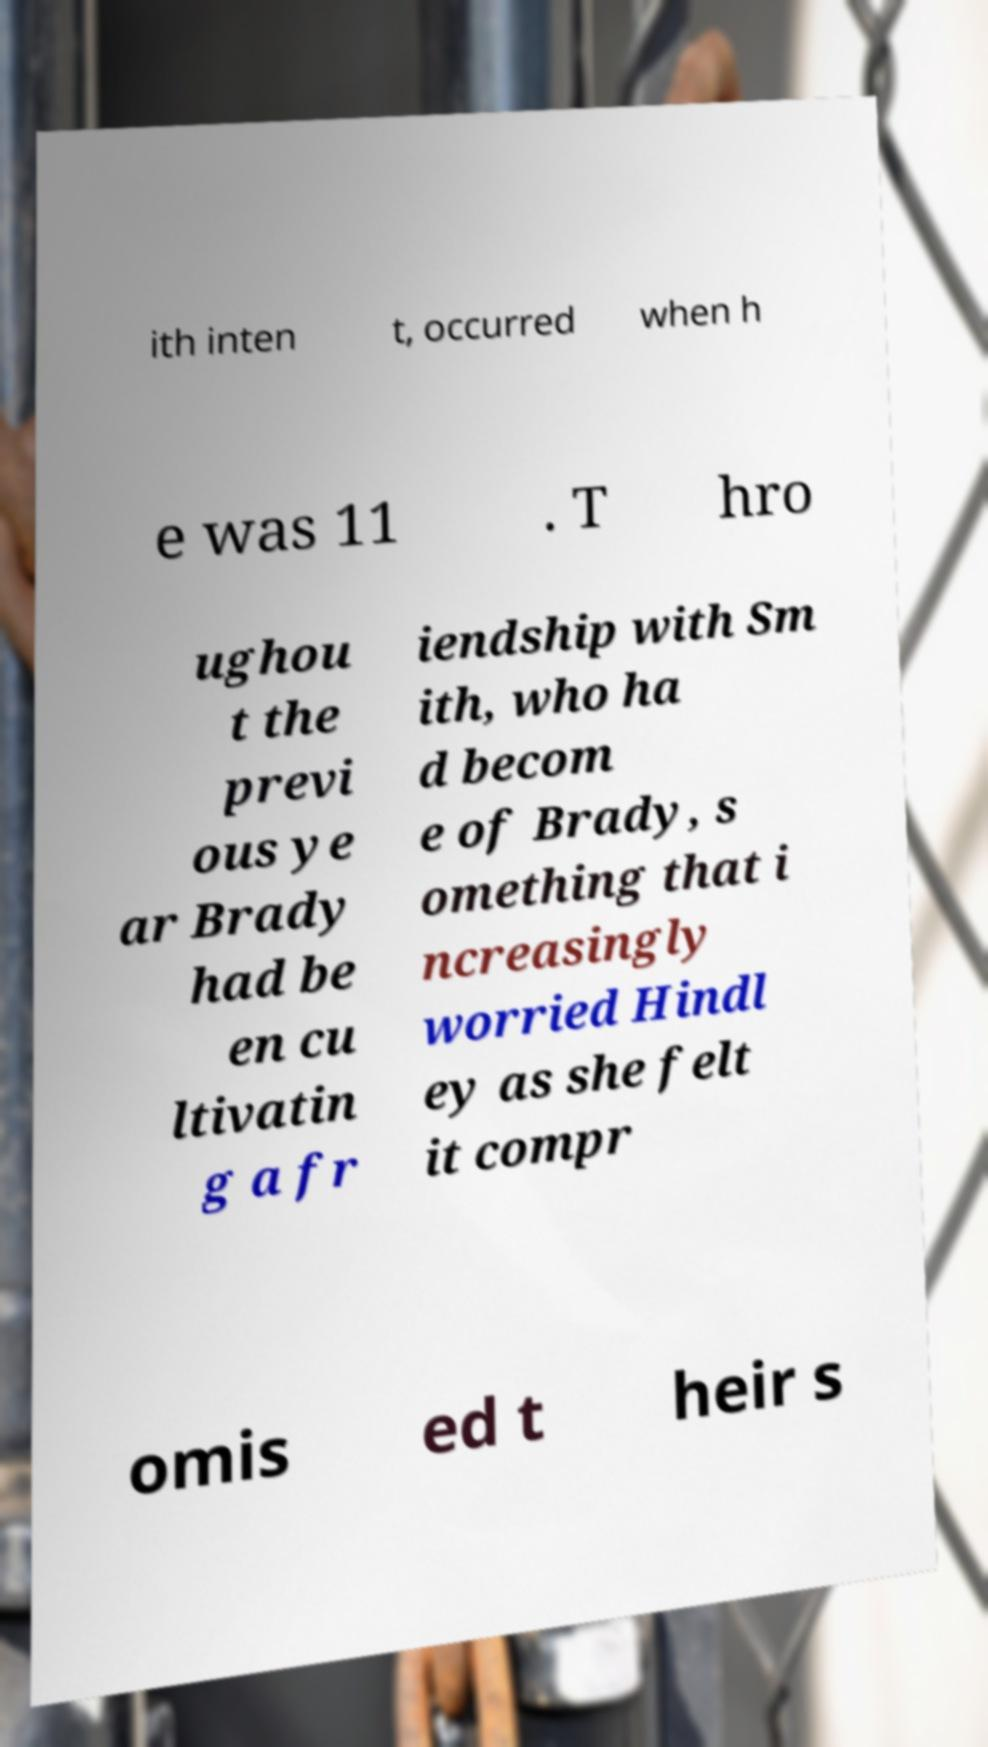What messages or text are displayed in this image? I need them in a readable, typed format. ith inten t, occurred when h e was 11 . T hro ughou t the previ ous ye ar Brady had be en cu ltivatin g a fr iendship with Sm ith, who ha d becom e of Brady, s omething that i ncreasingly worried Hindl ey as she felt it compr omis ed t heir s 